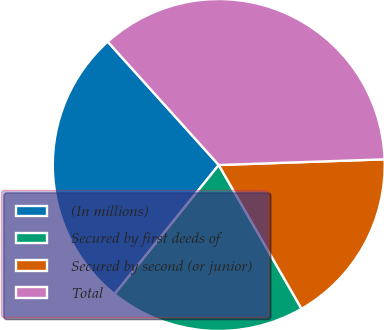Convert chart. <chart><loc_0><loc_0><loc_500><loc_500><pie_chart><fcel>(In millions)<fcel>Secured by first deeds of<fcel>Secured by second (or junior)<fcel>Total<nl><fcel>27.53%<fcel>19.12%<fcel>17.23%<fcel>36.12%<nl></chart> 